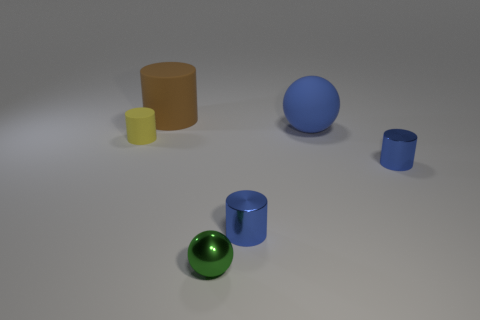What time of day or lighting conditions do these objects appear to be in? The lighting in the image is soft and diffuse, suggesting an indoor setting with ambient light sources that are not directly visible. Shadows cast by the objects are soft-edged and fall mostly to the right, which could imply a light source coming from the top left, outside of the frame. Does the lighting affect the color perception of these objects? The lighting conditions provide enough illumination to see the true colors of the objects without strong distortions. However, the softness of the lighting might slightly subdue the color vibrancy, offering a more muted representation compared to bright direct lighting. 